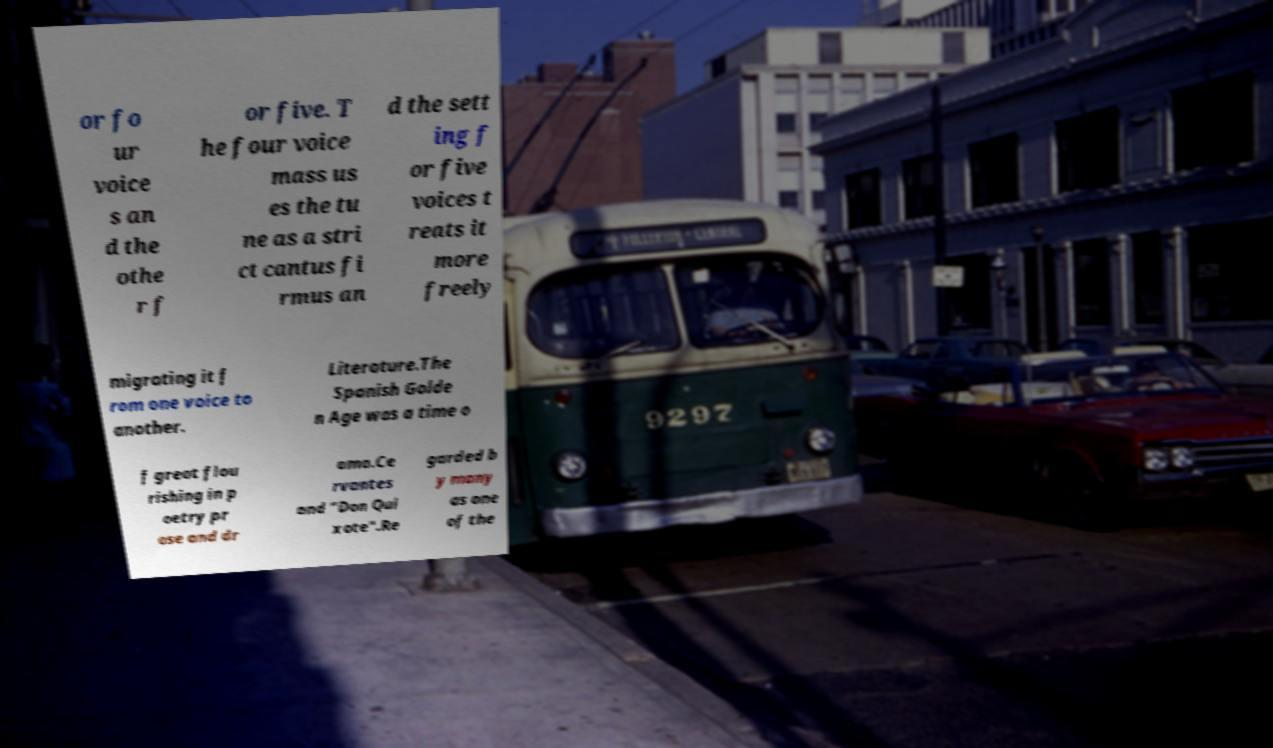Can you accurately transcribe the text from the provided image for me? or fo ur voice s an d the othe r f or five. T he four voice mass us es the tu ne as a stri ct cantus fi rmus an d the sett ing f or five voices t reats it more freely migrating it f rom one voice to another. Literature.The Spanish Golde n Age was a time o f great flou rishing in p oetry pr ose and dr ama.Ce rvantes and "Don Qui xote".Re garded b y many as one of the 